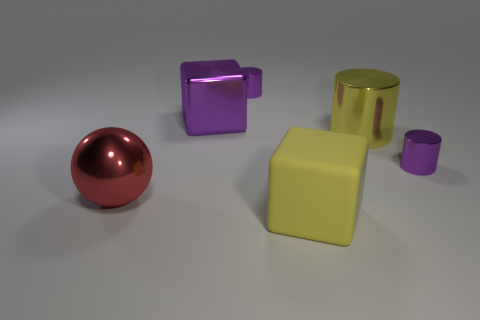Subtract all purple metal cylinders. How many cylinders are left? 1 Subtract all purple blocks. How many blocks are left? 1 Add 1 yellow metal cylinders. How many objects exist? 7 Subtract all balls. How many objects are left? 5 Subtract all gray cylinders. Subtract all brown spheres. How many cylinders are left? 3 Subtract all large yellow things. Subtract all large blocks. How many objects are left? 2 Add 4 large metal cylinders. How many large metal cylinders are left? 5 Add 1 small gray cubes. How many small gray cubes exist? 1 Subtract 1 yellow cylinders. How many objects are left? 5 Subtract 1 cylinders. How many cylinders are left? 2 